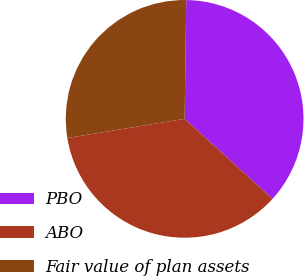Convert chart. <chart><loc_0><loc_0><loc_500><loc_500><pie_chart><fcel>PBO<fcel>ABO<fcel>Fair value of plan assets<nl><fcel>36.54%<fcel>35.67%<fcel>27.8%<nl></chart> 